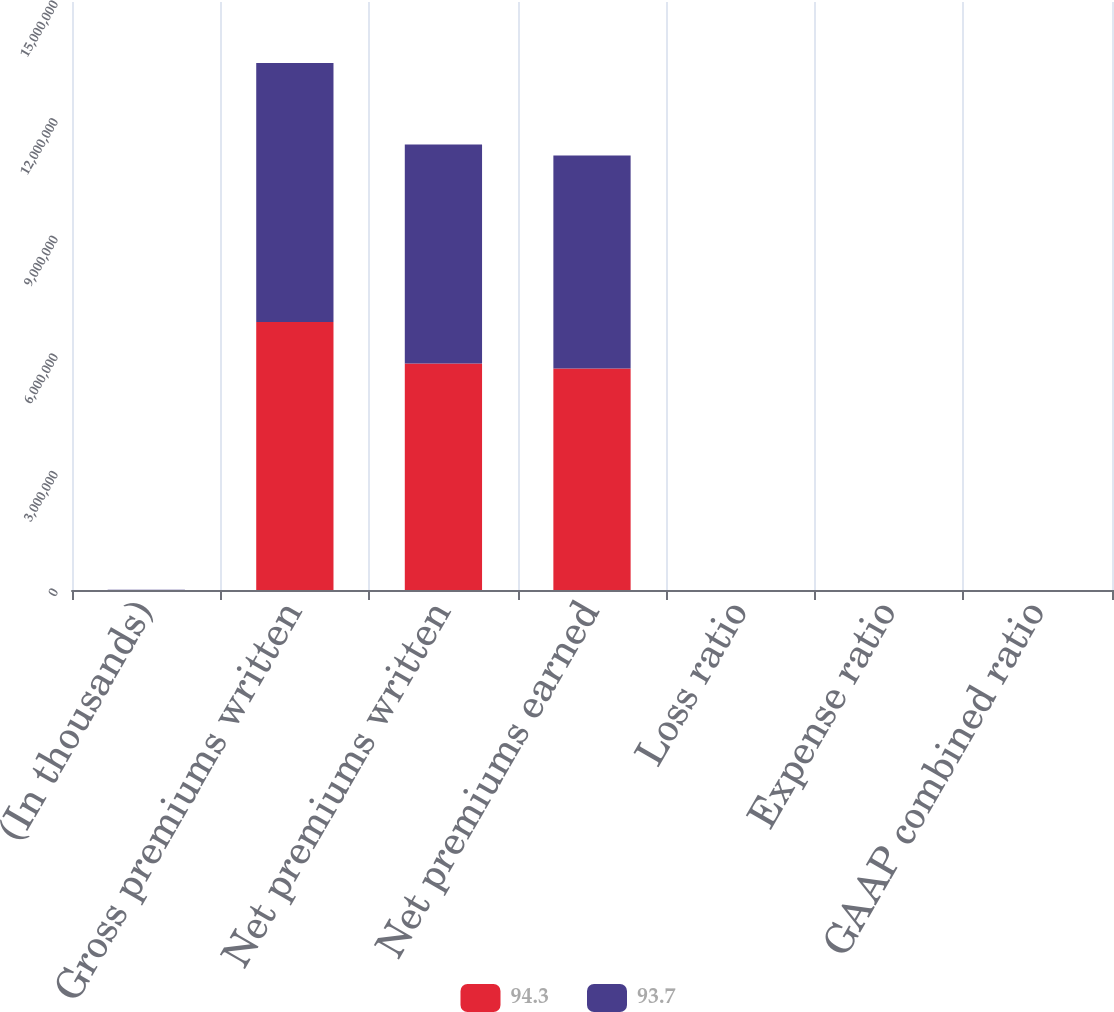Convert chart to OTSL. <chart><loc_0><loc_0><loc_500><loc_500><stacked_bar_chart><ecel><fcel>(In thousands)<fcel>Gross premiums written<fcel>Net premiums written<fcel>Net premiums earned<fcel>Loss ratio<fcel>Expense ratio<fcel>GAAP combined ratio<nl><fcel>94.3<fcel>2016<fcel>6.83506e+06<fcel>5.77591e+06<fcel>5.6529e+06<fcel>61<fcel>32.6<fcel>93.6<nl><fcel>93.7<fcel>2015<fcel>6.60749e+06<fcel>5.5914e+06<fcel>5.4315e+06<fcel>60.8<fcel>32.6<fcel>93.4<nl></chart> 